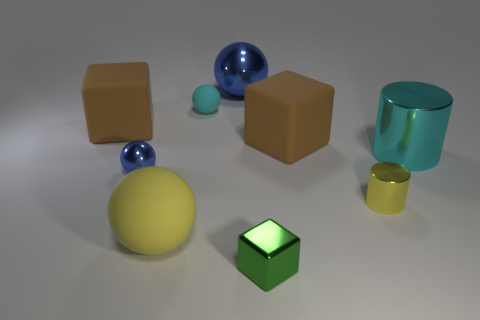Is the color of the large matte sphere the same as the tiny metallic cylinder?
Keep it short and to the point. Yes. What number of brown things are tiny metal blocks or large metallic cylinders?
Your response must be concise. 0. There is a green thing that is the same size as the yellow shiny object; what is its material?
Ensure brevity in your answer.  Metal. There is a small metallic object that is both behind the yellow ball and to the right of the large yellow matte object; what is its shape?
Make the answer very short. Cylinder. What is the color of the matte ball that is the same size as the yellow metallic object?
Provide a short and direct response. Cyan. Is the size of the blue sphere that is on the right side of the large yellow object the same as the brown cube to the left of the tiny shiny sphere?
Ensure brevity in your answer.  Yes. What is the size of the cyan cylinder that is to the right of the large matte object behind the brown cube right of the tiny cyan ball?
Provide a short and direct response. Large. The large thing that is in front of the cylinder left of the big cylinder is what shape?
Your response must be concise. Sphere. There is a cylinder right of the tiny yellow cylinder; is it the same color as the large matte ball?
Provide a succinct answer. No. The small thing that is to the right of the big yellow matte sphere and to the left of the small metal cube is what color?
Your response must be concise. Cyan. 